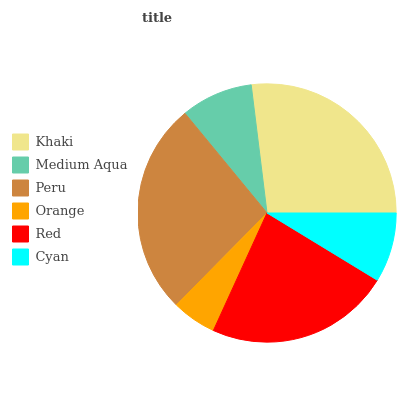Is Orange the minimum?
Answer yes or no. Yes. Is Khaki the maximum?
Answer yes or no. Yes. Is Medium Aqua the minimum?
Answer yes or no. No. Is Medium Aqua the maximum?
Answer yes or no. No. Is Khaki greater than Medium Aqua?
Answer yes or no. Yes. Is Medium Aqua less than Khaki?
Answer yes or no. Yes. Is Medium Aqua greater than Khaki?
Answer yes or no. No. Is Khaki less than Medium Aqua?
Answer yes or no. No. Is Red the high median?
Answer yes or no. Yes. Is Medium Aqua the low median?
Answer yes or no. Yes. Is Khaki the high median?
Answer yes or no. No. Is Peru the low median?
Answer yes or no. No. 